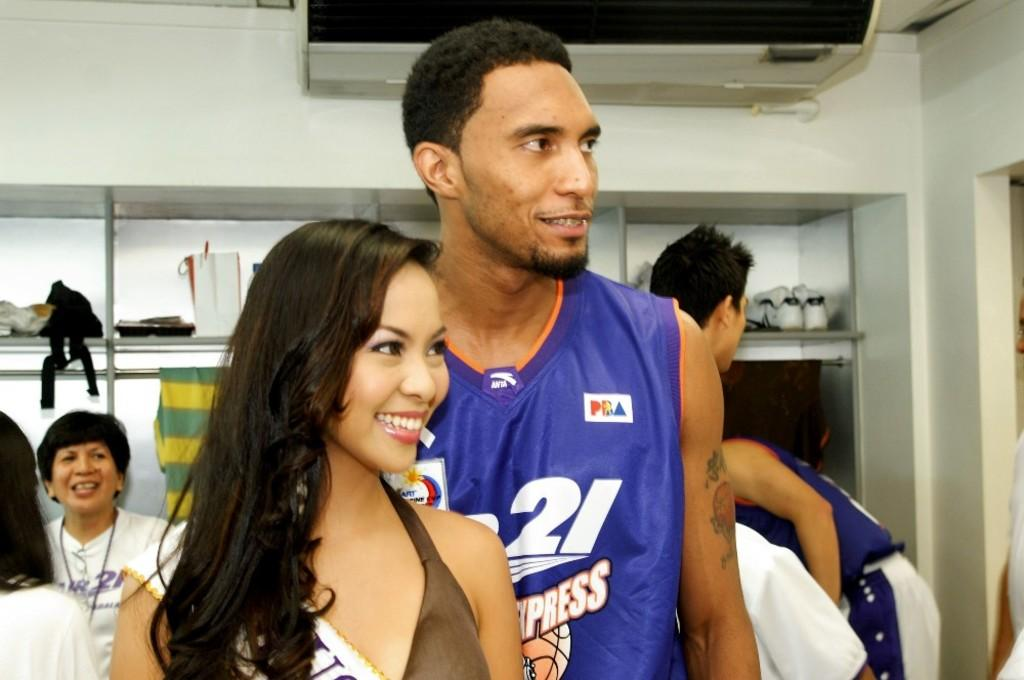<image>
Relay a brief, clear account of the picture shown. Basketball player number 21 stands behind a good looking woman. 